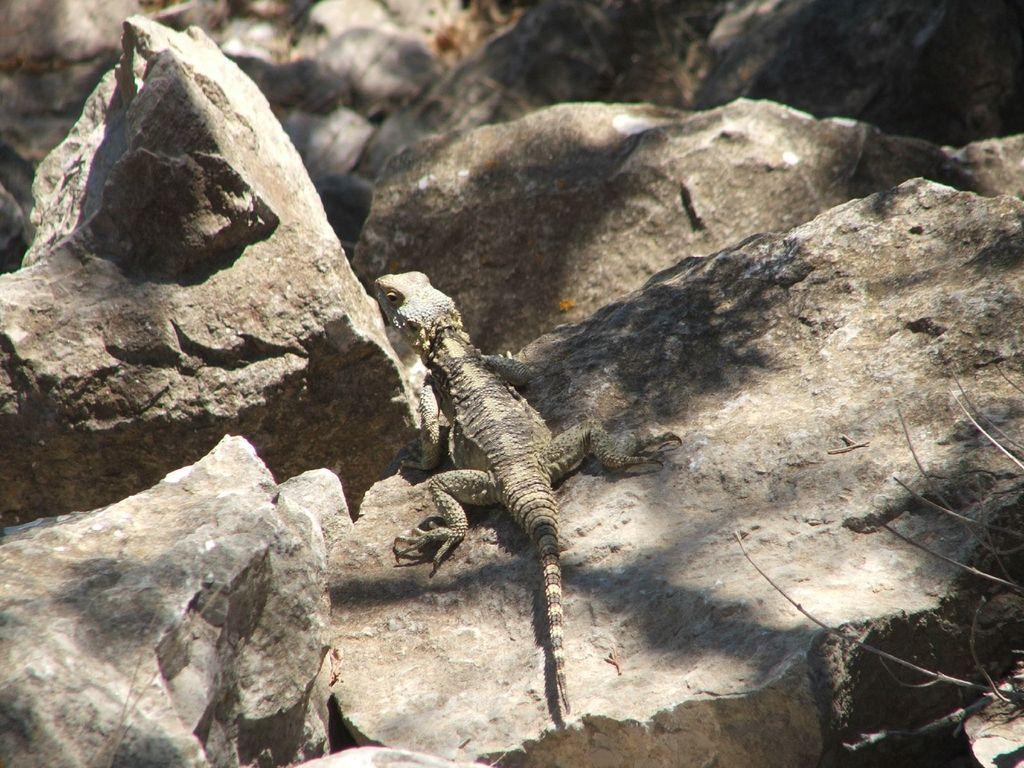Can you describe this image briefly? In the center of the image, we can see a lizard and in the background, there are rocks and we can see twigs. 